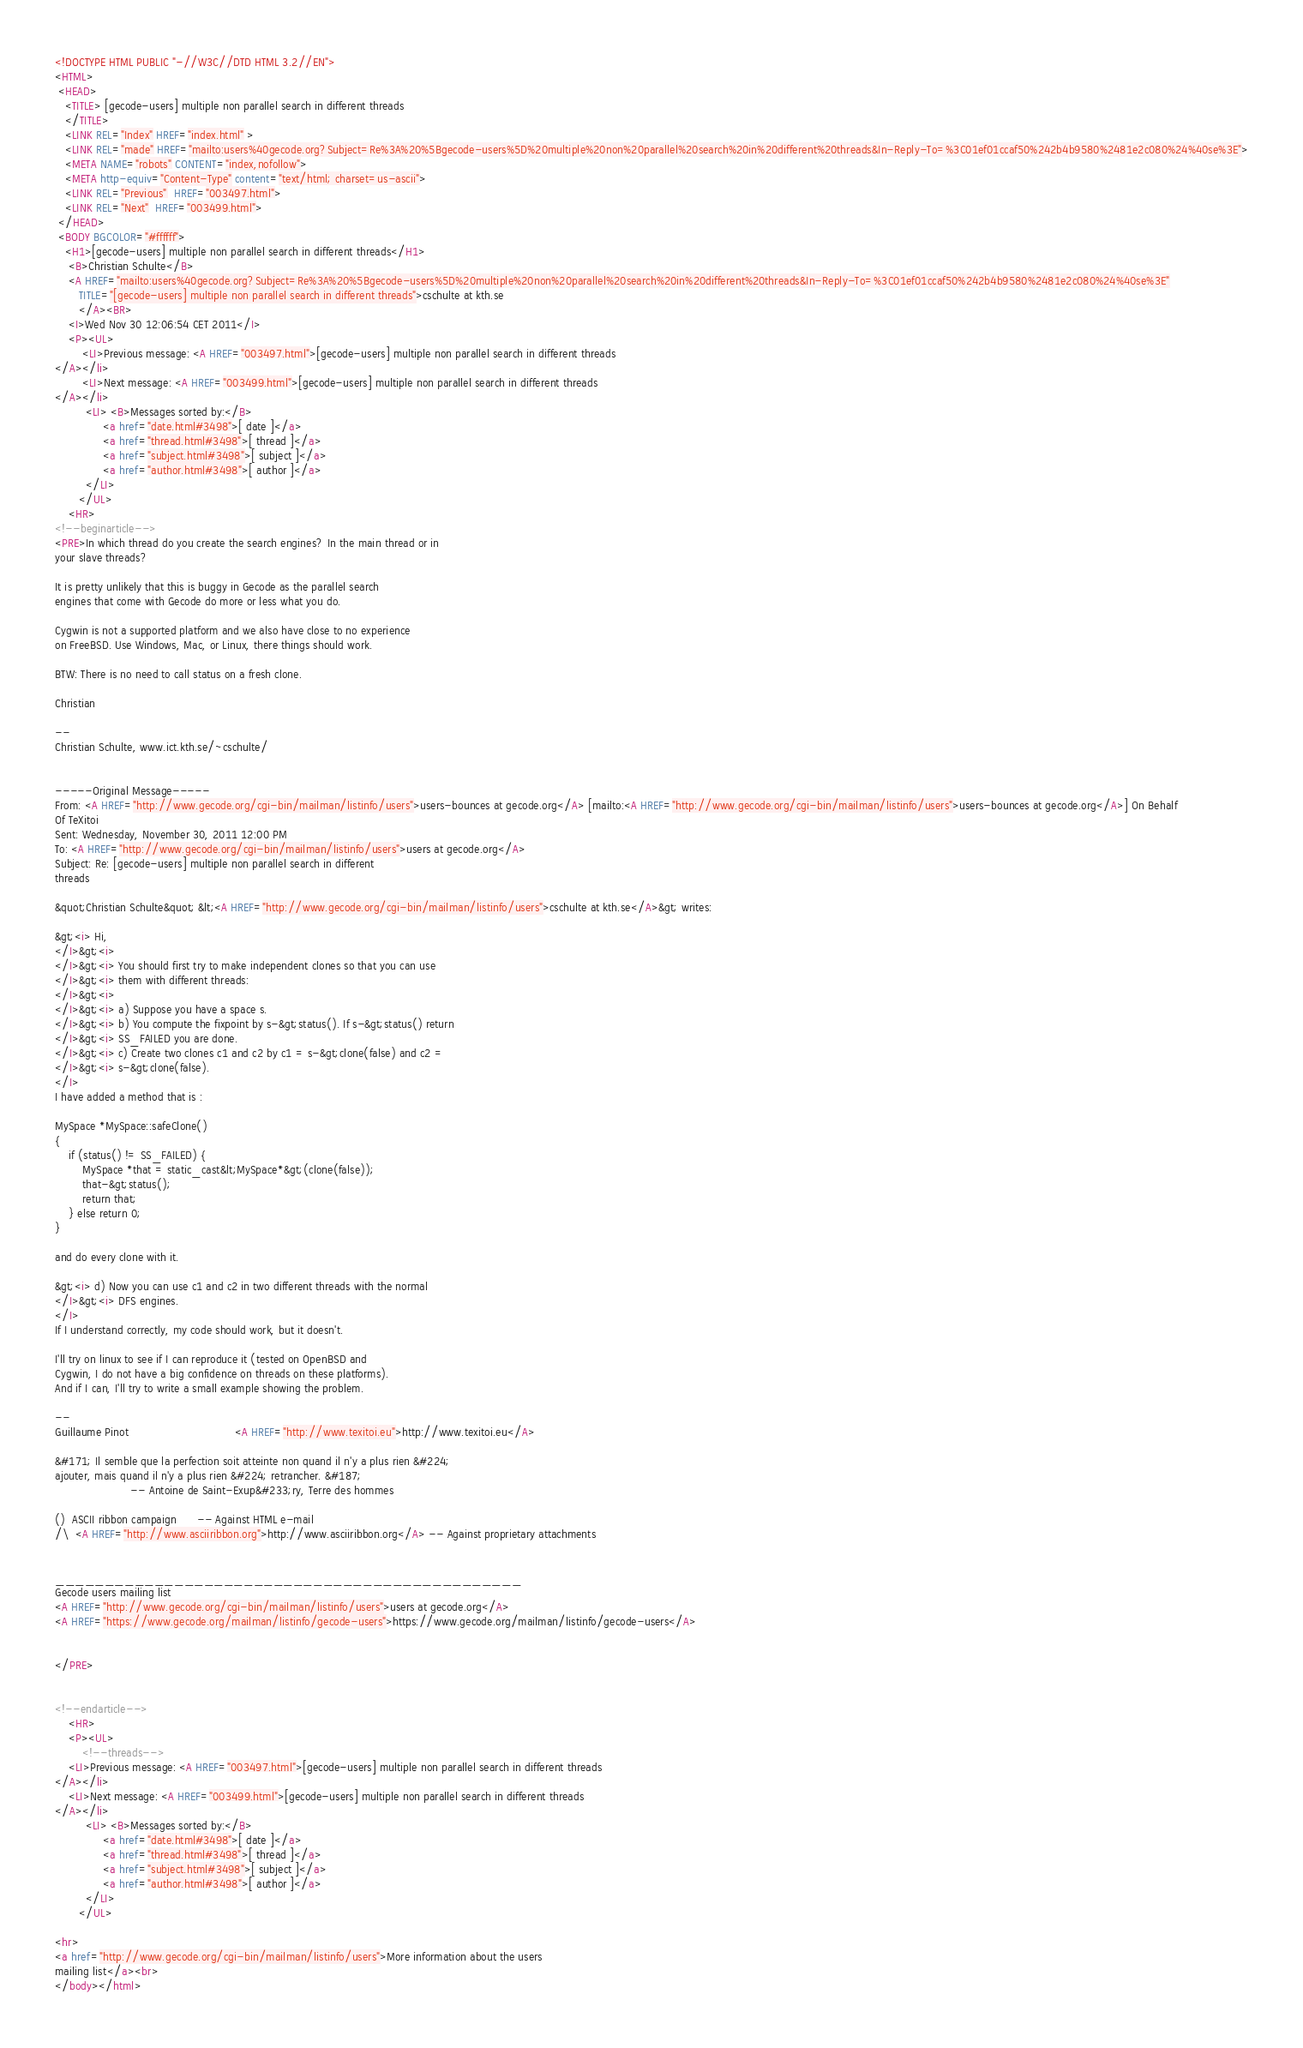<code> <loc_0><loc_0><loc_500><loc_500><_HTML_><!DOCTYPE HTML PUBLIC "-//W3C//DTD HTML 3.2//EN">
<HTML>
 <HEAD>
   <TITLE> [gecode-users] multiple non parallel search in different threads
   </TITLE>
   <LINK REL="Index" HREF="index.html" >
   <LINK REL="made" HREF="mailto:users%40gecode.org?Subject=Re%3A%20%5Bgecode-users%5D%20multiple%20non%20parallel%20search%20in%20different%20threads&In-Reply-To=%3C01ef01ccaf50%242b4b9580%2481e2c080%24%40se%3E">
   <META NAME="robots" CONTENT="index,nofollow">
   <META http-equiv="Content-Type" content="text/html; charset=us-ascii">
   <LINK REL="Previous"  HREF="003497.html">
   <LINK REL="Next"  HREF="003499.html">
 </HEAD>
 <BODY BGCOLOR="#ffffff">
   <H1>[gecode-users] multiple non parallel search in different threads</H1>
    <B>Christian Schulte</B> 
    <A HREF="mailto:users%40gecode.org?Subject=Re%3A%20%5Bgecode-users%5D%20multiple%20non%20parallel%20search%20in%20different%20threads&In-Reply-To=%3C01ef01ccaf50%242b4b9580%2481e2c080%24%40se%3E"
       TITLE="[gecode-users] multiple non parallel search in different threads">cschulte at kth.se
       </A><BR>
    <I>Wed Nov 30 12:06:54 CET 2011</I>
    <P><UL>
        <LI>Previous message: <A HREF="003497.html">[gecode-users] multiple non parallel search in different threads
</A></li>
        <LI>Next message: <A HREF="003499.html">[gecode-users] multiple non parallel search in different threads
</A></li>
         <LI> <B>Messages sorted by:</B> 
              <a href="date.html#3498">[ date ]</a>
              <a href="thread.html#3498">[ thread ]</a>
              <a href="subject.html#3498">[ subject ]</a>
              <a href="author.html#3498">[ author ]</a>
         </LI>
       </UL>
    <HR>  
<!--beginarticle-->
<PRE>In which thread do you create the search engines? In the main thread or in
your slave threads?

It is pretty unlikely that this is buggy in Gecode as the parallel search
engines that come with Gecode do more or less what you do.

Cygwin is not a supported platform and we also have close to no experience
on FreeBSD. Use Windows, Mac, or Linux, there things should work.

BTW: There is no need to call status on a fresh clone.

Christian

--
Christian Schulte, www.ict.kth.se/~cschulte/


-----Original Message-----
From: <A HREF="http://www.gecode.org/cgi-bin/mailman/listinfo/users">users-bounces at gecode.org</A> [mailto:<A HREF="http://www.gecode.org/cgi-bin/mailman/listinfo/users">users-bounces at gecode.org</A>] On Behalf
Of TeXitoi
Sent: Wednesday, November 30, 2011 12:00 PM
To: <A HREF="http://www.gecode.org/cgi-bin/mailman/listinfo/users">users at gecode.org</A>
Subject: Re: [gecode-users] multiple non parallel search in different
threads

&quot;Christian Schulte&quot; &lt;<A HREF="http://www.gecode.org/cgi-bin/mailman/listinfo/users">cschulte at kth.se</A>&gt; writes:

&gt;<i> Hi,
</I>&gt;<i> 
</I>&gt;<i> You should first try to make independent clones so that you can use 
</I>&gt;<i> them with different threads:
</I>&gt;<i> 
</I>&gt;<i> a) Suppose you have a space s.
</I>&gt;<i> b) You compute the fixpoint by s-&gt;status(). If s-&gt;status() return 
</I>&gt;<i> SS_FAILED you are done.
</I>&gt;<i> c) Create two clones c1 and c2 by c1 = s-&gt;clone(false) and c2 =
</I>&gt;<i> s-&gt;clone(false).
</I>
I have added a method that is :

MySpace *MySpace::safeClone()
{
    if (status() != SS_FAILED) {
        MySpace *that = static_cast&lt;MySpace*&gt;(clone(false));
        that-&gt;status();
        return that;
    } else return 0;
}

and do every clone with it.

&gt;<i> d) Now you can use c1 and c2 in two different threads with the normal 
</I>&gt;<i> DFS engines.
</I>
If I understand correctly, my code should work, but it doesn't.

I'll try on linux to see if I can reproduce it (tested on OpenBSD and
Cygwin, I do not have a big confidence on threads on these platforms).
And if I can, I'll try to write a small example showing the problem.

-- 
Guillaume Pinot                               <A HREF="http://www.texitoi.eu">http://www.texitoi.eu</A>

&#171; Il semble que la perfection soit atteinte non quand il n'y a plus rien &#224;
ajouter, mais quand il n'y a plus rien &#224; retrancher. &#187;
                      -- Antoine de Saint-Exup&#233;ry, Terre des hommes

()  ASCII ribbon campaign      -- Against HTML e-mail
/\  <A HREF="http://www.asciiribbon.org">http://www.asciiribbon.org</A> -- Against proprietary attachments


_______________________________________________
Gecode users mailing list
<A HREF="http://www.gecode.org/cgi-bin/mailman/listinfo/users">users at gecode.org</A>
<A HREF="https://www.gecode.org/mailman/listinfo/gecode-users">https://www.gecode.org/mailman/listinfo/gecode-users</A>


</PRE>


<!--endarticle-->
    <HR>
    <P><UL>
        <!--threads-->
	<LI>Previous message: <A HREF="003497.html">[gecode-users] multiple non parallel search in different threads
</A></li>
	<LI>Next message: <A HREF="003499.html">[gecode-users] multiple non parallel search in different threads
</A></li>
         <LI> <B>Messages sorted by:</B> 
              <a href="date.html#3498">[ date ]</a>
              <a href="thread.html#3498">[ thread ]</a>
              <a href="subject.html#3498">[ subject ]</a>
              <a href="author.html#3498">[ author ]</a>
         </LI>
       </UL>

<hr>
<a href="http://www.gecode.org/cgi-bin/mailman/listinfo/users">More information about the users
mailing list</a><br>
</body></html>
</code> 